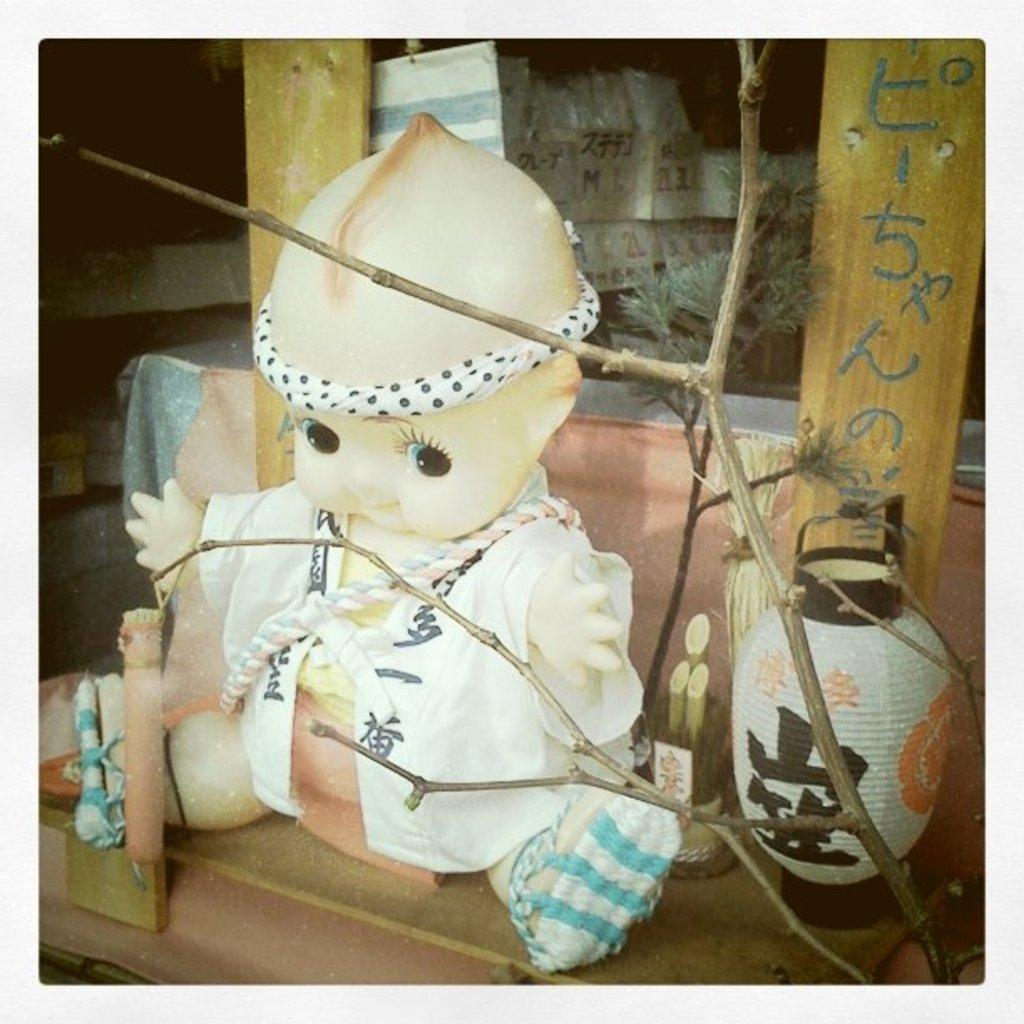What is the main object in the image? There is a doll in the image. What is placed beside the doll? There is a lantern beside the doll. What can be seen in front of the lantern? There are branches of a dry tree in front of the lantern. What can be seen in the background of the image? There are goods visible in the background of the image. How many fingers can be seen on the doll's hand in the image? The image does not show the doll's hand or any fingers, so it is not possible to answer that question. 